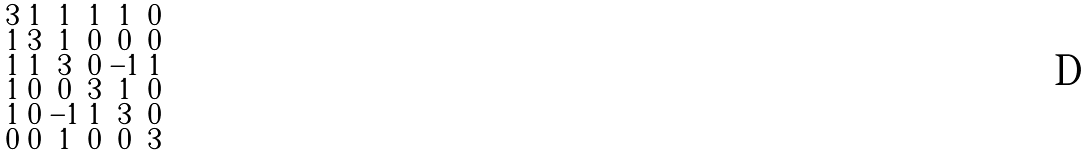<formula> <loc_0><loc_0><loc_500><loc_500>\begin{smallmatrix} 3 & 1 & 1 & 1 & 1 & 0 \\ 1 & 3 & 1 & 0 & 0 & 0 \\ 1 & 1 & 3 & 0 & - 1 & 1 \\ 1 & 0 & 0 & 3 & 1 & 0 \\ 1 & 0 & - 1 & 1 & 3 & 0 \\ 0 & 0 & 1 & 0 & 0 & 3 \end{smallmatrix}</formula> 